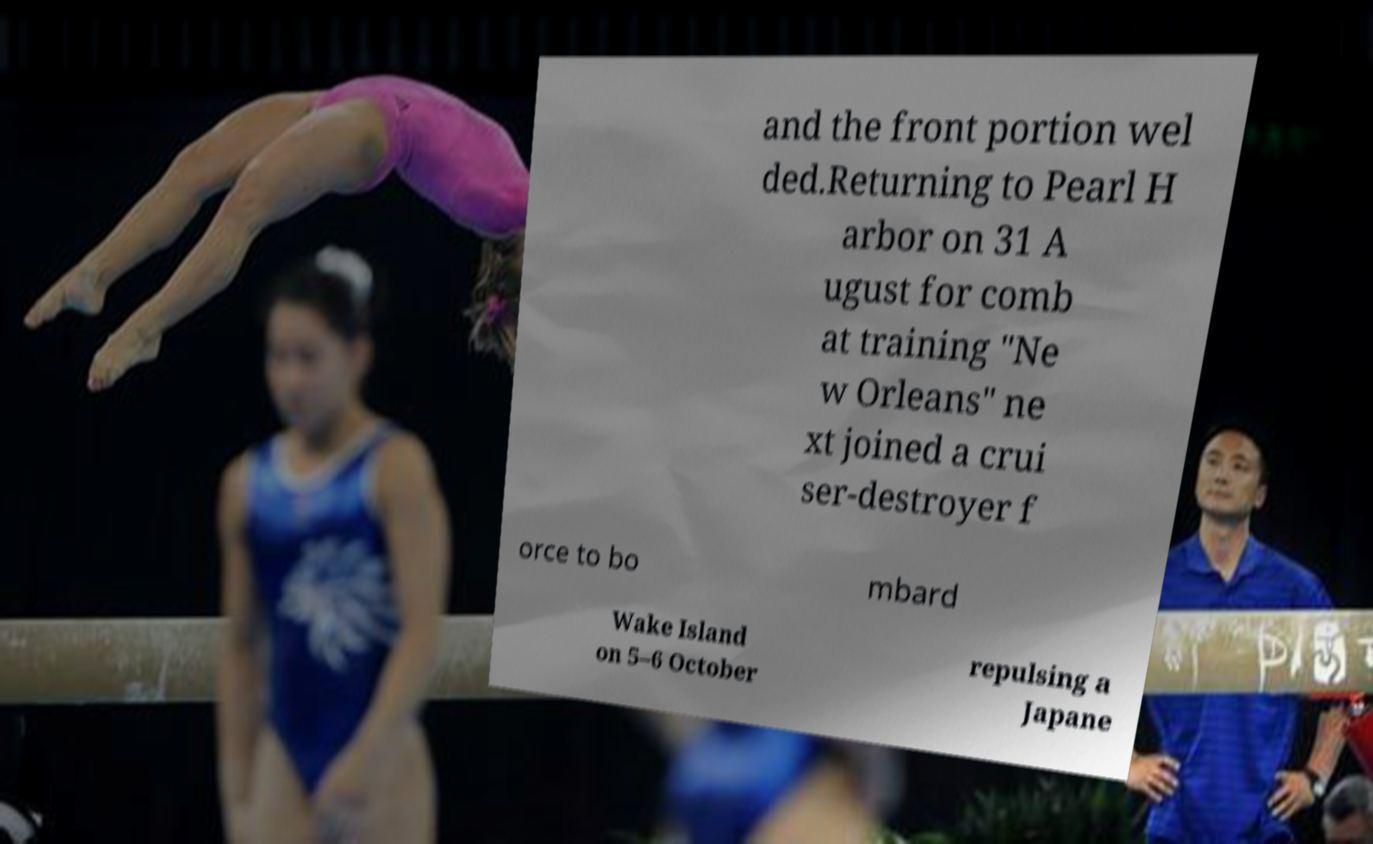What messages or text are displayed in this image? I need them in a readable, typed format. and the front portion wel ded.Returning to Pearl H arbor on 31 A ugust for comb at training "Ne w Orleans" ne xt joined a crui ser-destroyer f orce to bo mbard Wake Island on 5–6 October repulsing a Japane 